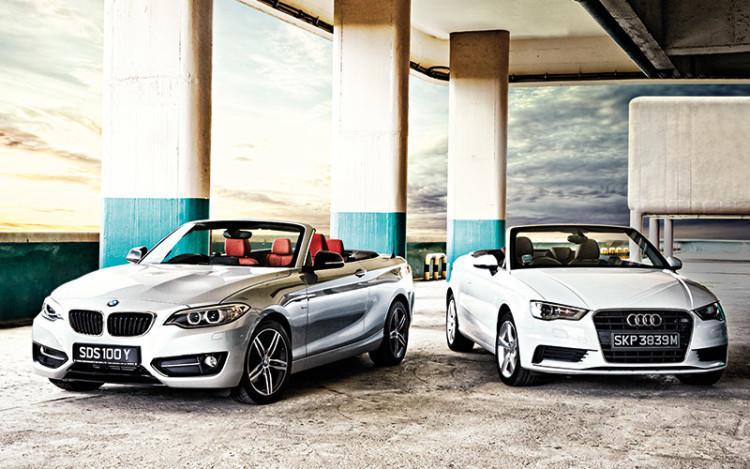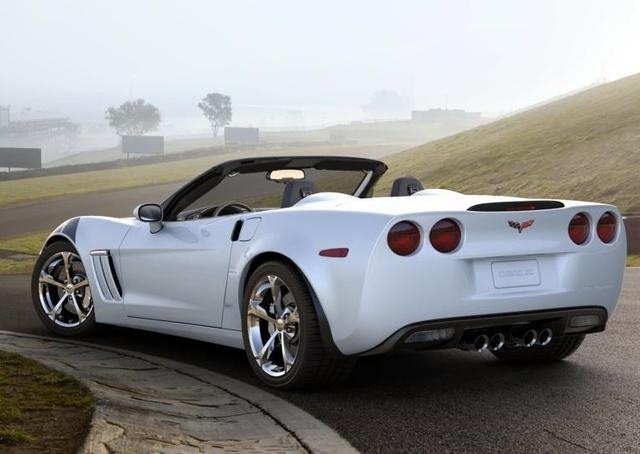The first image is the image on the left, the second image is the image on the right. Considering the images on both sides, is "The car on the right is light blue." valid? Answer yes or no. No. The first image is the image on the left, the second image is the image on the right. Considering the images on both sides, is "An image shows the back end and tail light of a driverless white convertible with its top down." valid? Answer yes or no. Yes. 